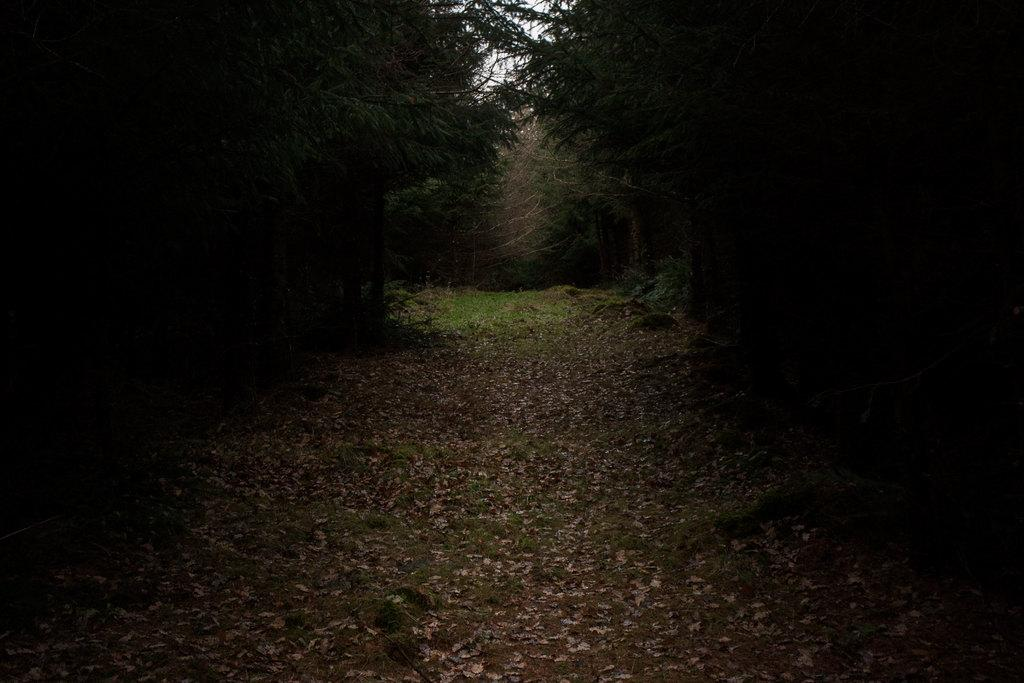What type of vegetation can be seen on the ground in the image? There are dried leaves and dried grass on the ground in the image. What can be seen in the background of the image? There are trees visible in the background of the image. What type of lock can be seen on the tree in the image? There is no lock present on the tree in the image. Can you see any sails in the image? There are no sails visible in the image. 